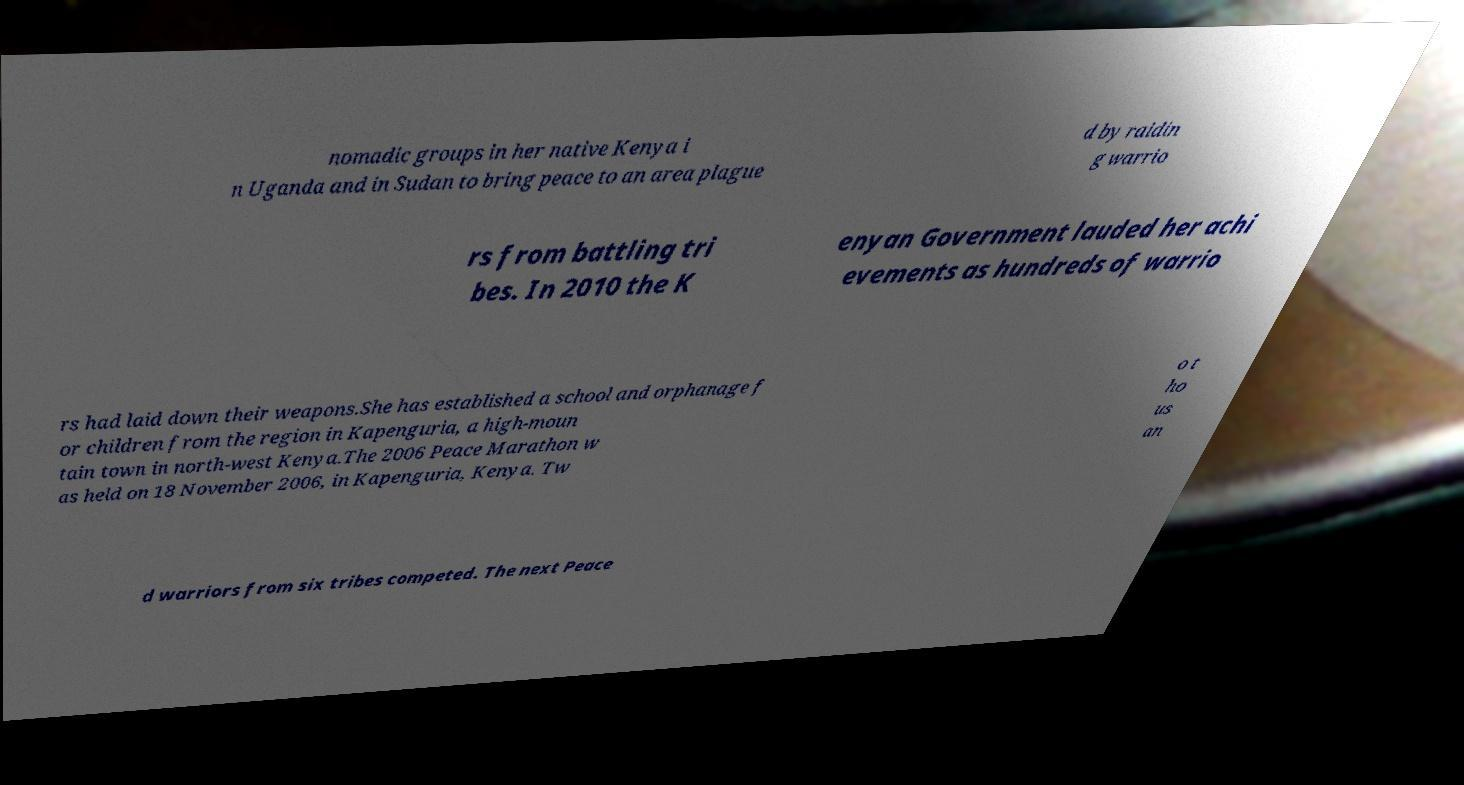What messages or text are displayed in this image? I need them in a readable, typed format. nomadic groups in her native Kenya i n Uganda and in Sudan to bring peace to an area plague d by raidin g warrio rs from battling tri bes. In 2010 the K enyan Government lauded her achi evements as hundreds of warrio rs had laid down their weapons.She has established a school and orphanage f or children from the region in Kapenguria, a high-moun tain town in north-west Kenya.The 2006 Peace Marathon w as held on 18 November 2006, in Kapenguria, Kenya. Tw o t ho us an d warriors from six tribes competed. The next Peace 